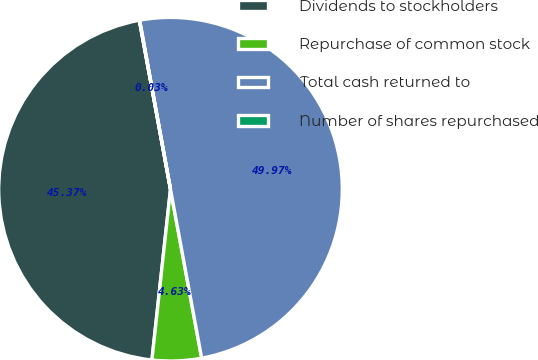Convert chart to OTSL. <chart><loc_0><loc_0><loc_500><loc_500><pie_chart><fcel>Dividends to stockholders<fcel>Repurchase of common stock<fcel>Total cash returned to<fcel>Number of shares repurchased<nl><fcel>45.37%<fcel>4.63%<fcel>49.97%<fcel>0.03%<nl></chart> 